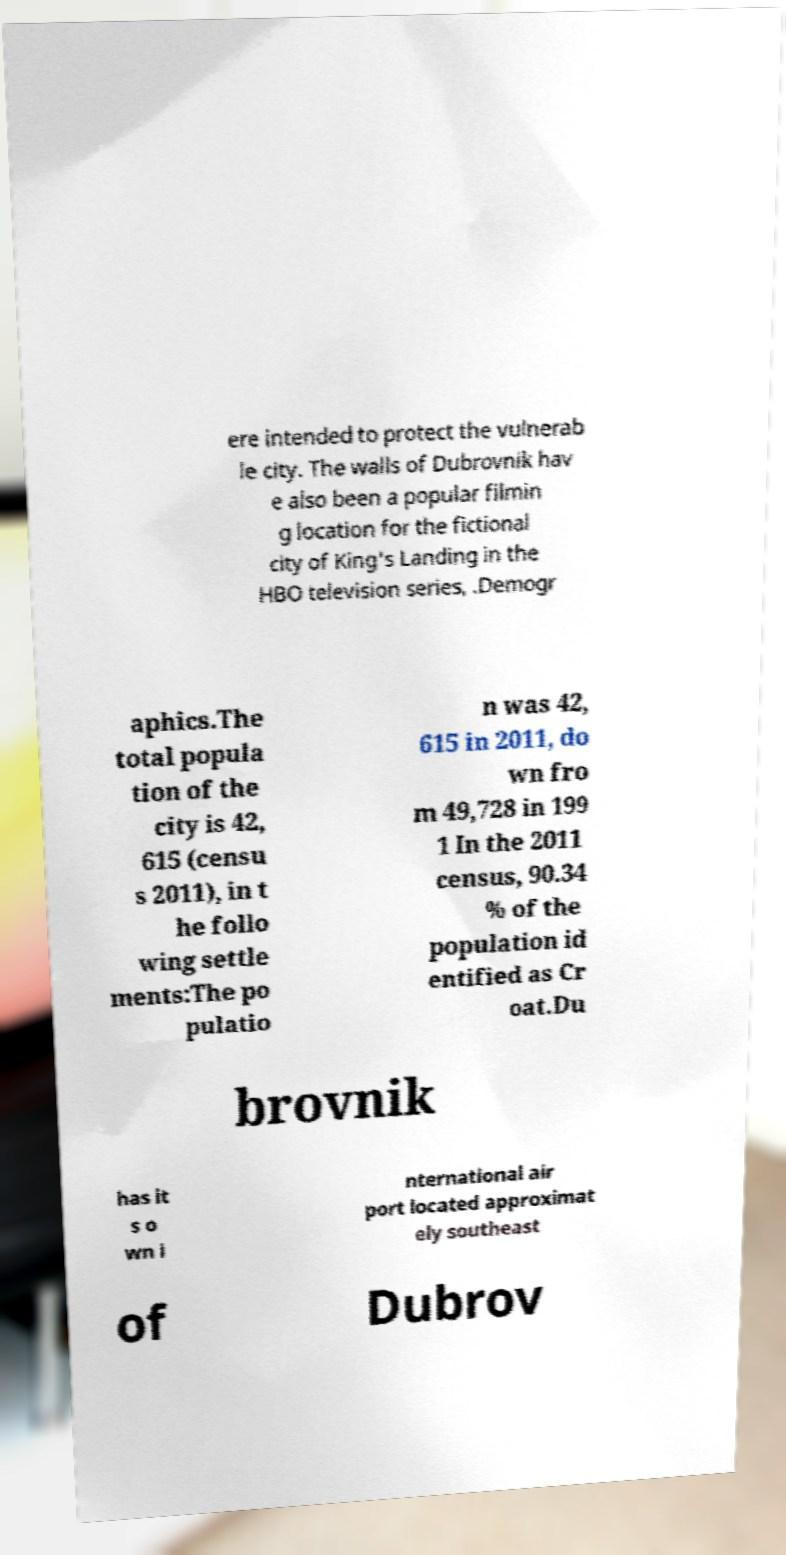There's text embedded in this image that I need extracted. Can you transcribe it verbatim? ere intended to protect the vulnerab le city. The walls of Dubrovnik hav e also been a popular filmin g location for the fictional city of King's Landing in the HBO television series, .Demogr aphics.The total popula tion of the city is 42, 615 (censu s 2011), in t he follo wing settle ments:The po pulatio n was 42, 615 in 2011, do wn fro m 49,728 in 199 1 In the 2011 census, 90.34 % of the population id entified as Cr oat.Du brovnik has it s o wn i nternational air port located approximat ely southeast of Dubrov 